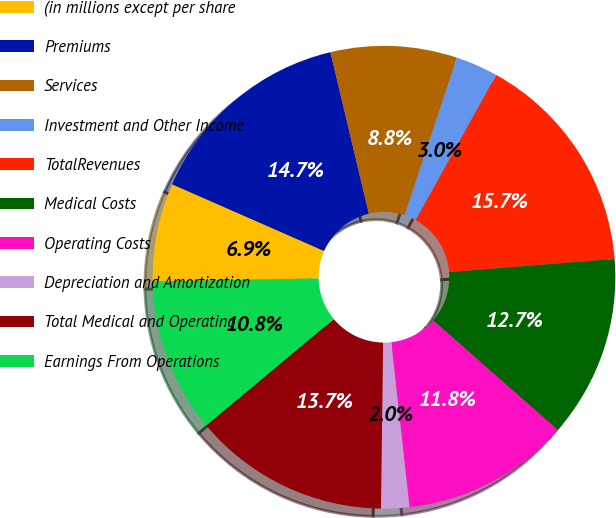Convert chart to OTSL. <chart><loc_0><loc_0><loc_500><loc_500><pie_chart><fcel>(in millions except per share<fcel>Premiums<fcel>Services<fcel>Investment and Other Income<fcel>TotalRevenues<fcel>Medical Costs<fcel>Operating Costs<fcel>Depreciation and Amortization<fcel>Total Medical and Operating<fcel>Earnings From Operations<nl><fcel>6.87%<fcel>14.7%<fcel>8.83%<fcel>2.95%<fcel>15.68%<fcel>12.74%<fcel>11.76%<fcel>1.97%<fcel>13.72%<fcel>10.78%<nl></chart> 